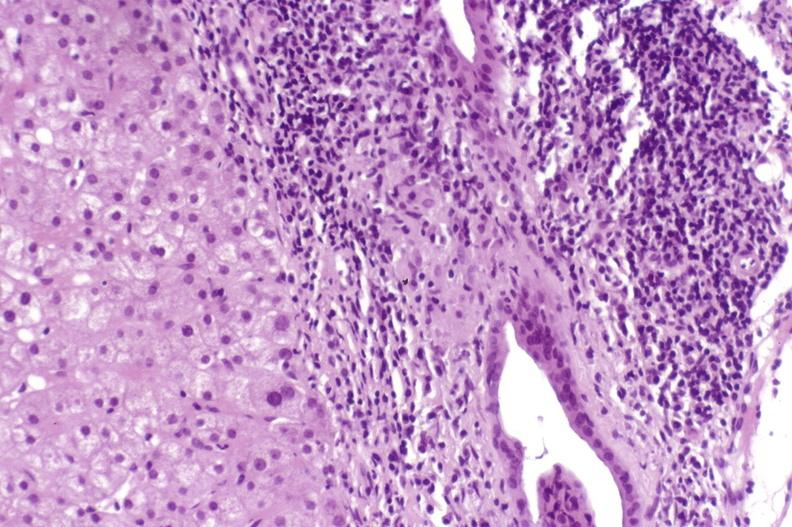s focal hemorrhagic infarction well shown present?
Answer the question using a single word or phrase. No 